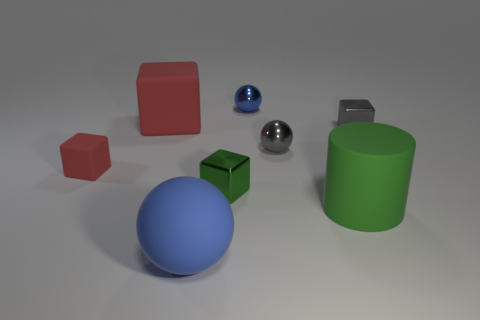Subtract all tiny spheres. How many spheres are left? 1 Subtract all gray spheres. How many spheres are left? 2 Add 1 blocks. How many objects exist? 9 Add 4 small red blocks. How many small red blocks are left? 5 Add 8 yellow metallic spheres. How many yellow metallic spheres exist? 8 Subtract 1 gray cubes. How many objects are left? 7 Subtract all cylinders. How many objects are left? 7 Subtract all blue cubes. Subtract all cyan cylinders. How many cubes are left? 4 Subtract all gray spheres. How many red cubes are left? 2 Subtract all tiny gray metal balls. Subtract all big yellow matte balls. How many objects are left? 7 